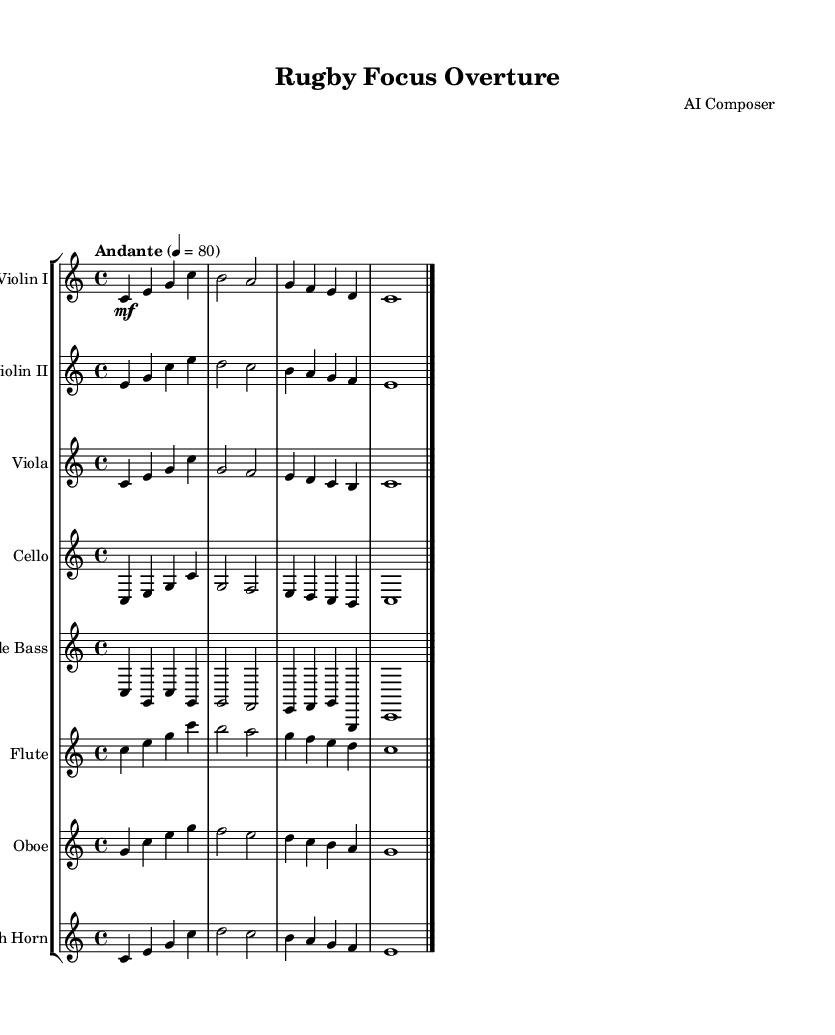What is the key signature of this music? The key signature is indicated at the beginning of the score and shows no sharps or flats, which corresponds to C major.
Answer: C major What is the time signature of this piece? The time signature is located at the beginning of the score, which is 4/4, indicating four beats per measure.
Answer: 4/4 What is the tempo marking of this music? The tempo marking is found at the beginning after the time signature, where it states "Andante" with a metronome marking of 80.
Answer: Andante Which instruments are included in the score? The printed score lists a total of seven instruments: Violin I, Violin II, Viola, Cello, Double Bass, Flute, Oboe, and French Horn; all these are labeled at the start of each staff.
Answer: Violin I, Violin II, Viola, Cello, Double Bass, Flute, Oboe, French Horn How many measures are there in the piece? By counting the measures represented in the score, there are a total of 4 measures shown within each staff section.
Answer: 4 What is the dynamics marking for the first violin part? The dynamics marking for the first violin part is indicated as "mf," which denotes mezzo-forte, meaning moderately loud.
Answer: mf What type of composition does this piece represent? The piece is structured as a classical orchestral piece, aiming to help listeners with focus and concentration during training, indicated by its orchestral arrangement.
Answer: Orchestral 